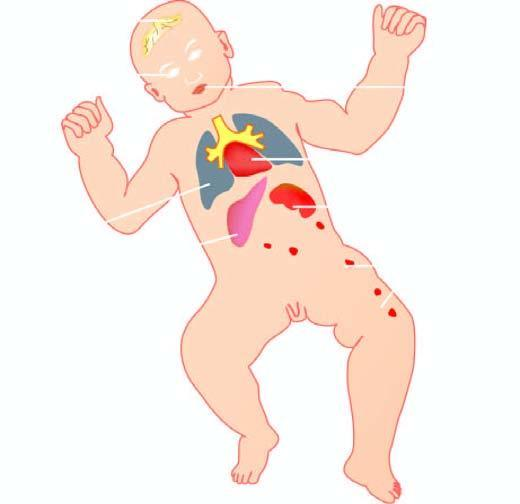what is lesions produced by?
Answer the question using a single word or phrase. Torch complex infection in foetus in utero 